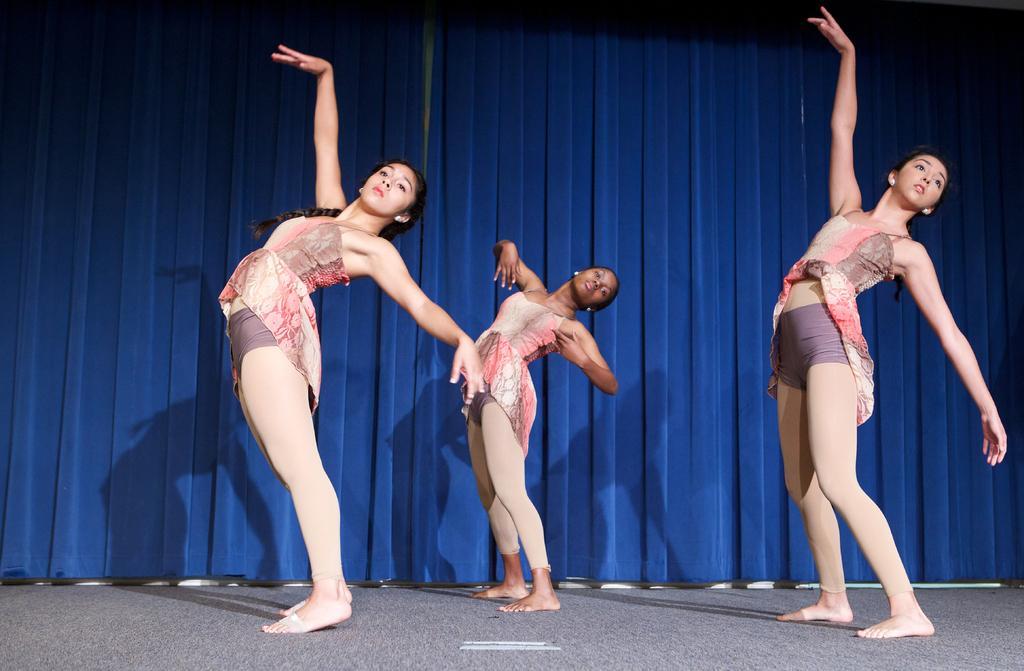How would you summarize this image in a sentence or two? Here in this picture we can see three women wearing same kind of costume and dancing on the floor and behind them we can see a curtain present. 